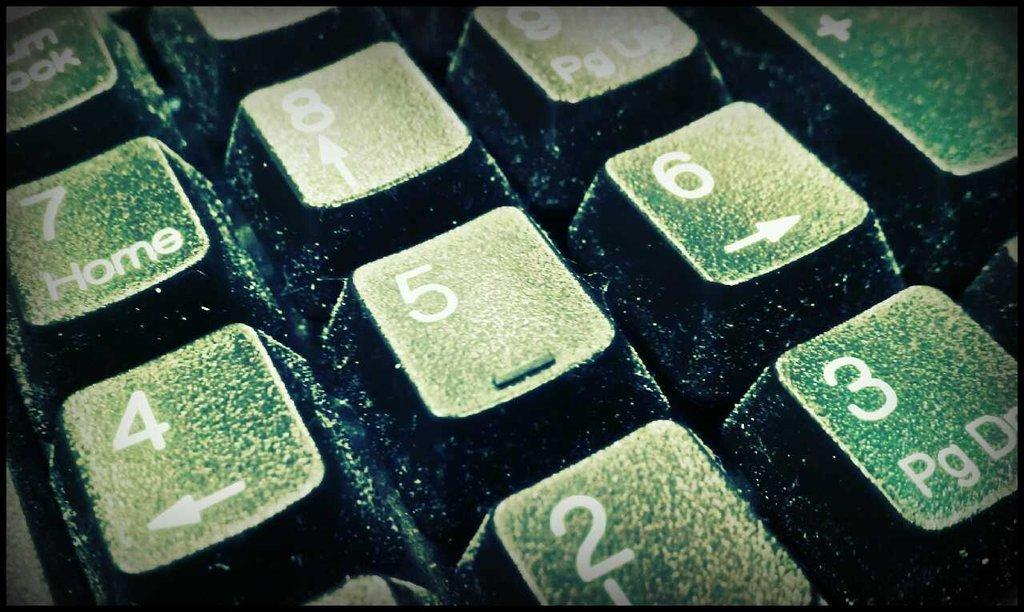<image>
Provide a brief description of the given image. A closeup of the numerical keys on a keyboard is centered on the 5. 